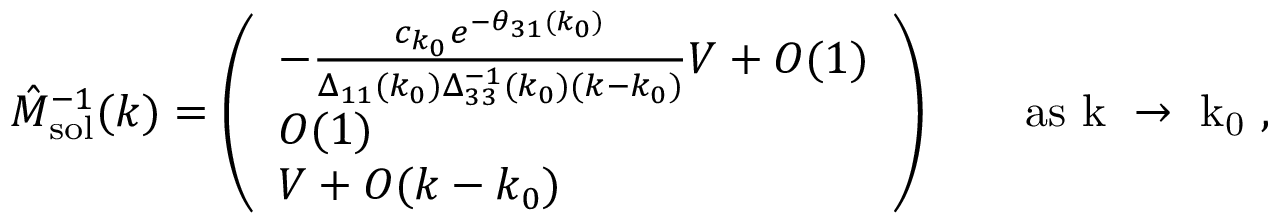<formula> <loc_0><loc_0><loc_500><loc_500>\hat { M } _ { s o l } ^ { - 1 } ( k ) = \left ( \begin{array} { l } { - \frac { c _ { k _ { 0 } } e ^ { - \theta _ { 3 1 } ( k _ { 0 } ) } } { \Delta _ { 1 1 } ( k _ { 0 } ) \Delta _ { 3 3 } ^ { - 1 } ( k _ { 0 } ) ( k - k _ { 0 } ) } V + O ( 1 ) } \\ { O ( 1 ) } \\ { V + O ( k - k _ { 0 } ) } \end{array} \right ) \quad a s k \to k _ { 0 } ,</formula> 